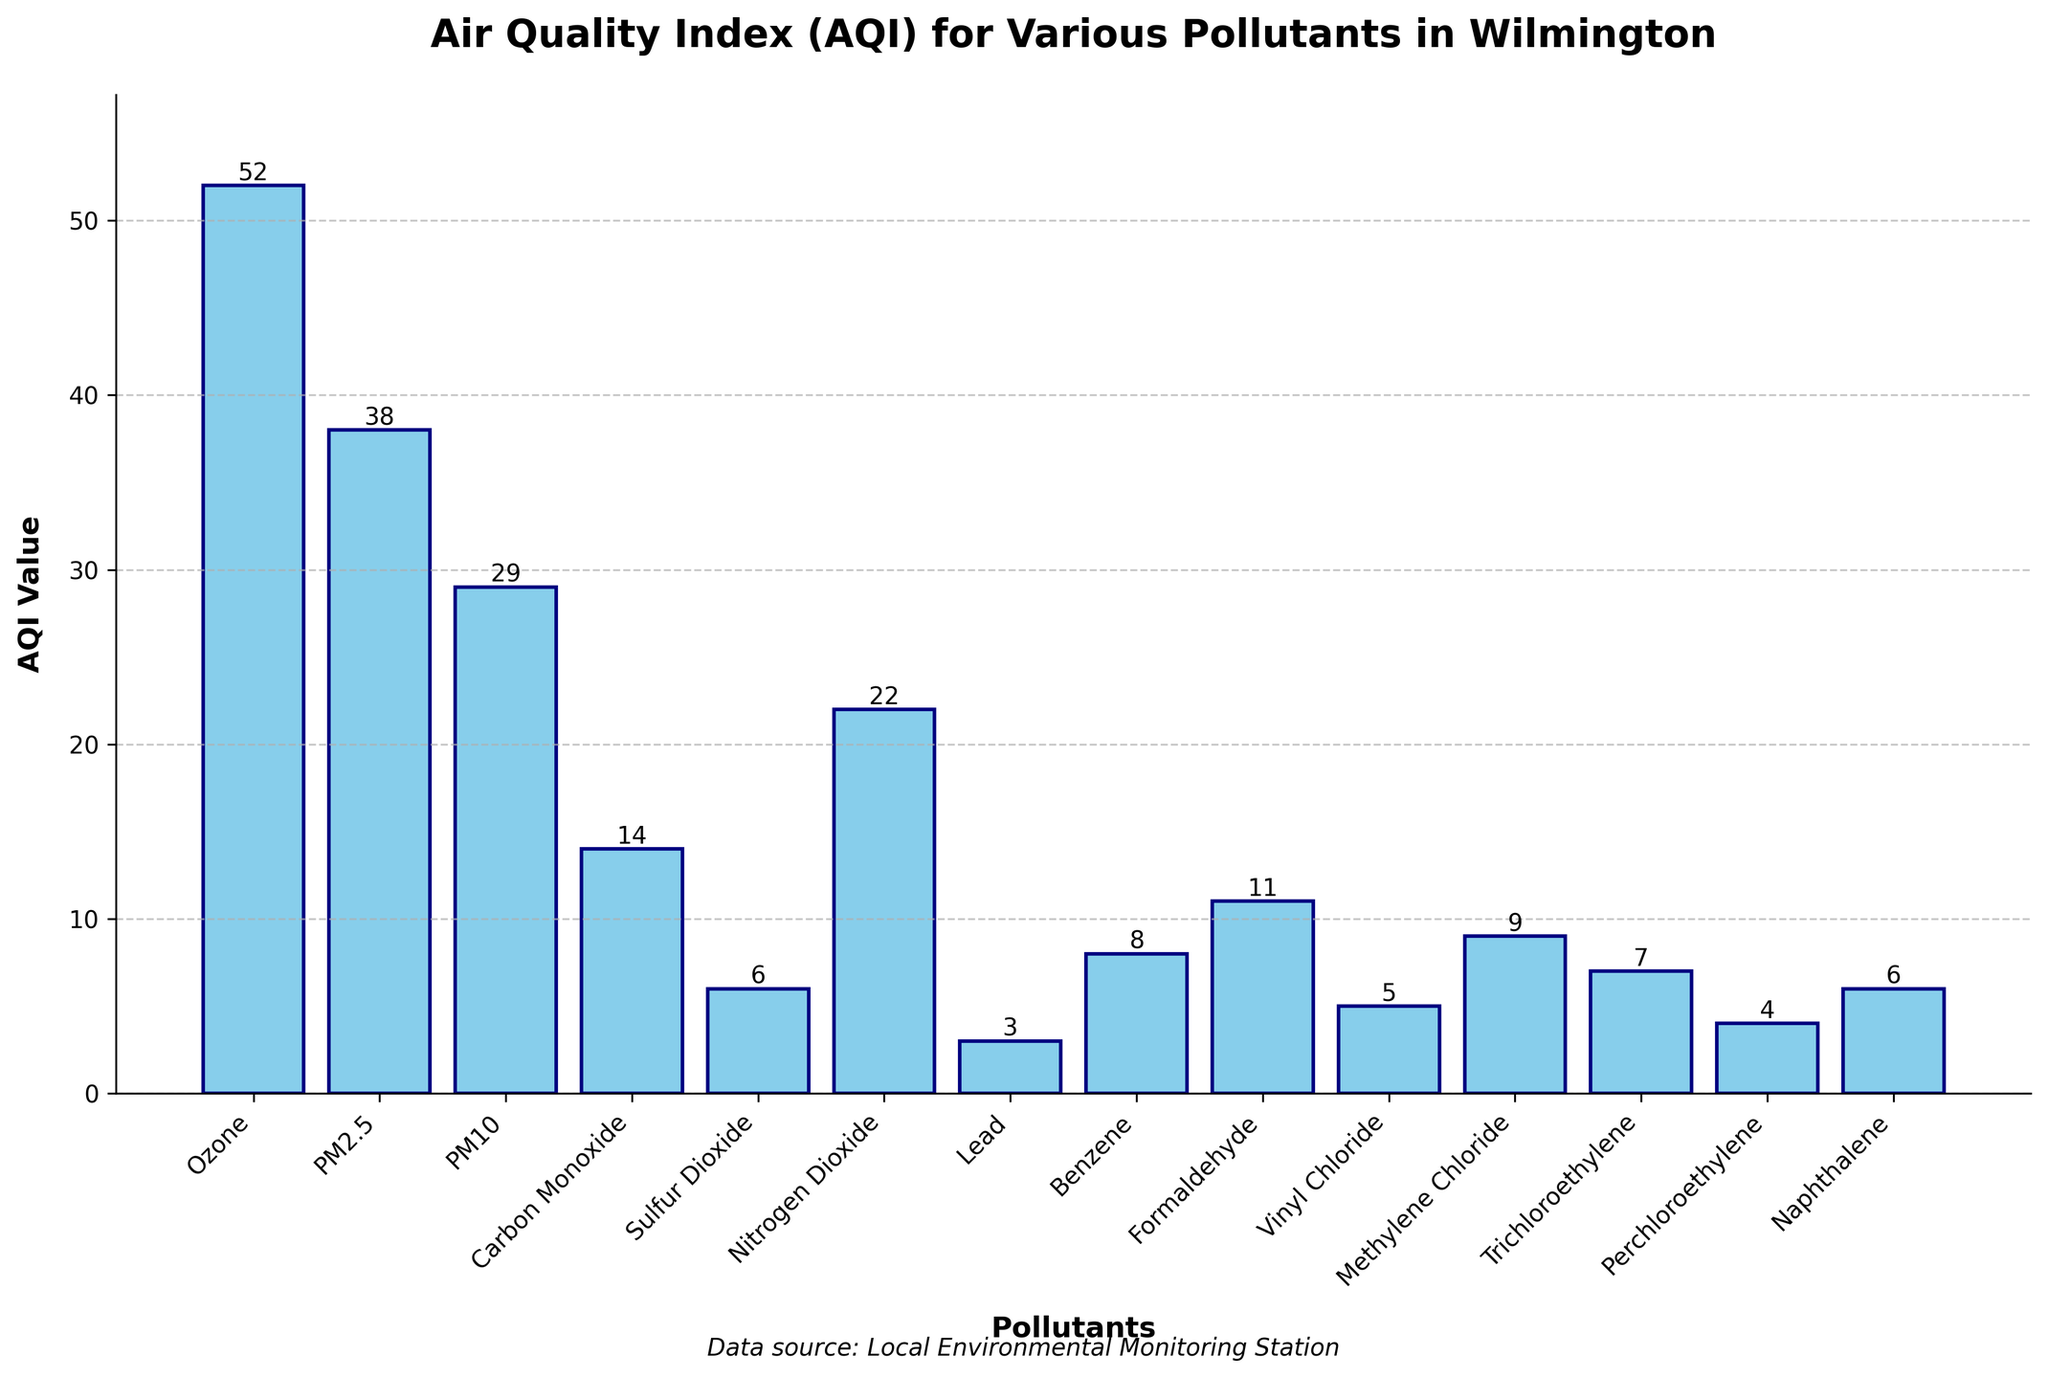What's the pollutant with the highest AQI value? By looking at the heights of the bars on the chart, the tallest bar corresponds to 'Ozone' with an AQI value of 52.
Answer: Ozone Which pollutant has the second highest AQI value? Observing the bar heights, the second tallest bar belongs to 'PM2.5' with an AQI value of 38.
Answer: PM2.5 How much higher is the AQI value of Ozone compared to Nitrogen Dioxide? The AQI value of Ozone is 52 and that of Nitrogen Dioxide is 22. The difference is calculated as 52 - 22 = 30.
Answer: 30 What's the average AQI value of Carbon Monoxide, Benzene, and Formaldehyde? Sum the AQI values of Carbon Monoxide (14), Benzene (8), and Formaldehyde (11) to get 14 + 8 + 11 = 33. The average is then 33 / 3 = 11.
Answer: 11 Which pollutant shows a lower AQI, Vinyl Chloride or Methylene Chloride? By comparing the heights of the bars, the AQI value for Vinyl Chloride is 5 and for Methylene Chloride is 9. So, Vinyl Chloride has a lower AQI.
Answer: Vinyl Chloride What is the total AQI value for Sulfur Dioxide, Lead, and Trichloroethylene? Sum the AQI values of Sulfur Dioxide (6), Lead (3), and Trichloroethylene (7) to get 6 + 3 + 7 = 16.
Answer: 16 Which AQI values are greater than 10 but less than 40? By inspecting the bar heights, the pollutants with AQI values within this range are: Nitrogen Dioxide (22), PM10 (29), Formaldehyde (11), and Carbon Monoxide (14).
Answer: Nitrogen Dioxide, PM10, Formaldehyde, Carbon Monoxide What is the median AQI value for all pollutants? To find the median, list AQI values in ascending order: 3, 4, 5, 6, 6, 7, 8, 9, 11, 14, 22, 29, 38, 52. Since the list has 14 values, median is average of 7th and 8th: (8 + 9)/2 = 8.5.
Answer: 8.5 How many pollutants have an AQI value less than 10? From the bar lengths, the pollutants with AQI < 10 are: Lead (3), Perchloroethylene (4), Vinyl Chloride (5), Methylene Chloride (9), Naphthalene (6), Sulfur Dioxide (6), and Trichloroethylene (7). Counting these gives 7.
Answer: 7 